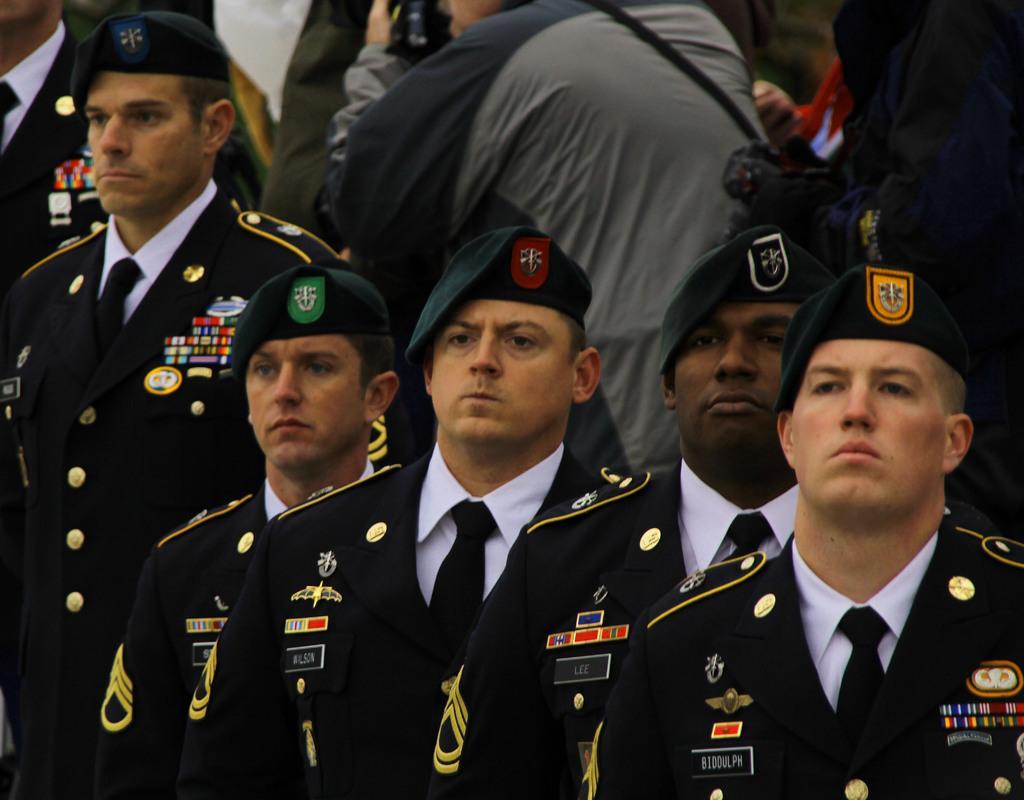In one or two sentences, can you explain what this image depicts? In the picture I can see people are standing among them some of them are wearing uniforms and hats. 